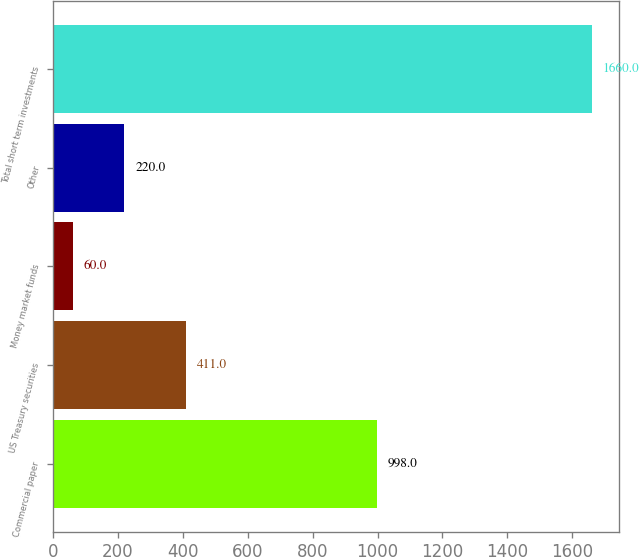Convert chart to OTSL. <chart><loc_0><loc_0><loc_500><loc_500><bar_chart><fcel>Commercial paper<fcel>US Treasury securities<fcel>Money market funds<fcel>Other<fcel>Total short term investments<nl><fcel>998<fcel>411<fcel>60<fcel>220<fcel>1660<nl></chart> 